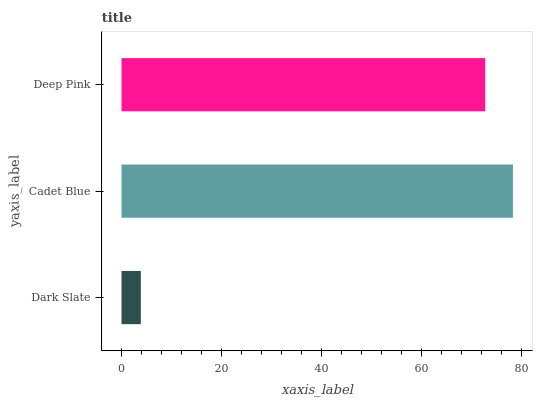Is Dark Slate the minimum?
Answer yes or no. Yes. Is Cadet Blue the maximum?
Answer yes or no. Yes. Is Deep Pink the minimum?
Answer yes or no. No. Is Deep Pink the maximum?
Answer yes or no. No. Is Cadet Blue greater than Deep Pink?
Answer yes or no. Yes. Is Deep Pink less than Cadet Blue?
Answer yes or no. Yes. Is Deep Pink greater than Cadet Blue?
Answer yes or no. No. Is Cadet Blue less than Deep Pink?
Answer yes or no. No. Is Deep Pink the high median?
Answer yes or no. Yes. Is Deep Pink the low median?
Answer yes or no. Yes. Is Cadet Blue the high median?
Answer yes or no. No. Is Dark Slate the low median?
Answer yes or no. No. 